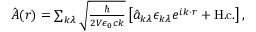<formula> <loc_0><loc_0><loc_500><loc_500>\begin{array} { r } { \hat { A } ( r ) = \sum _ { k \lambda } \sqrt { \frac { } { 2 V \epsilon _ { 0 } c k } } \left [ \hat { a } _ { k \lambda } \epsilon _ { k \lambda } e ^ { i k \cdot r } + H . c . \right ] , } \end{array}</formula> 